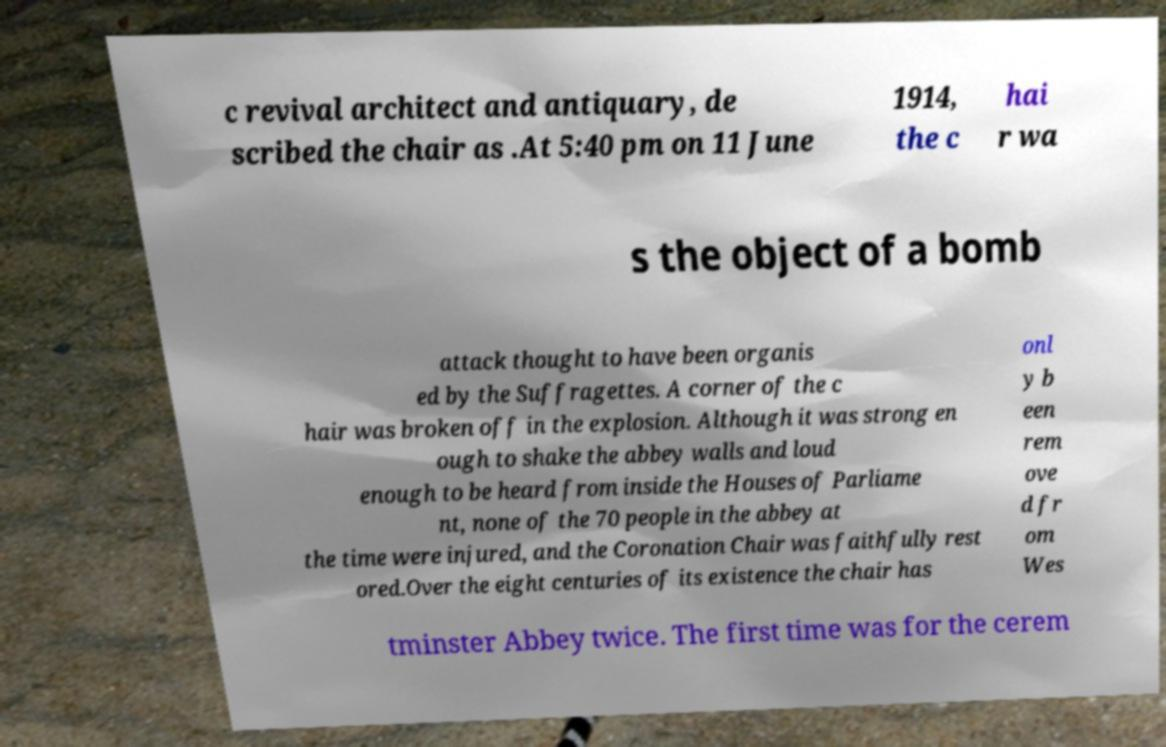Please identify and transcribe the text found in this image. c revival architect and antiquary, de scribed the chair as .At 5:40 pm on 11 June 1914, the c hai r wa s the object of a bomb attack thought to have been organis ed by the Suffragettes. A corner of the c hair was broken off in the explosion. Although it was strong en ough to shake the abbey walls and loud enough to be heard from inside the Houses of Parliame nt, none of the 70 people in the abbey at the time were injured, and the Coronation Chair was faithfully rest ored.Over the eight centuries of its existence the chair has onl y b een rem ove d fr om Wes tminster Abbey twice. The first time was for the cerem 